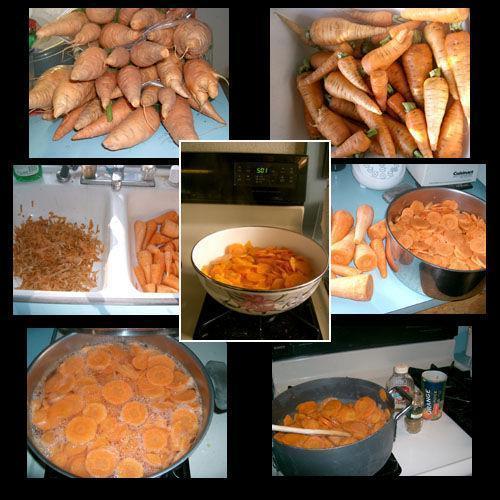How many ovens are visible?
Give a very brief answer. 3. How many bowls are in the picture?
Give a very brief answer. 4. How many sinks are there?
Give a very brief answer. 2. How many carrots are there?
Give a very brief answer. 2. 